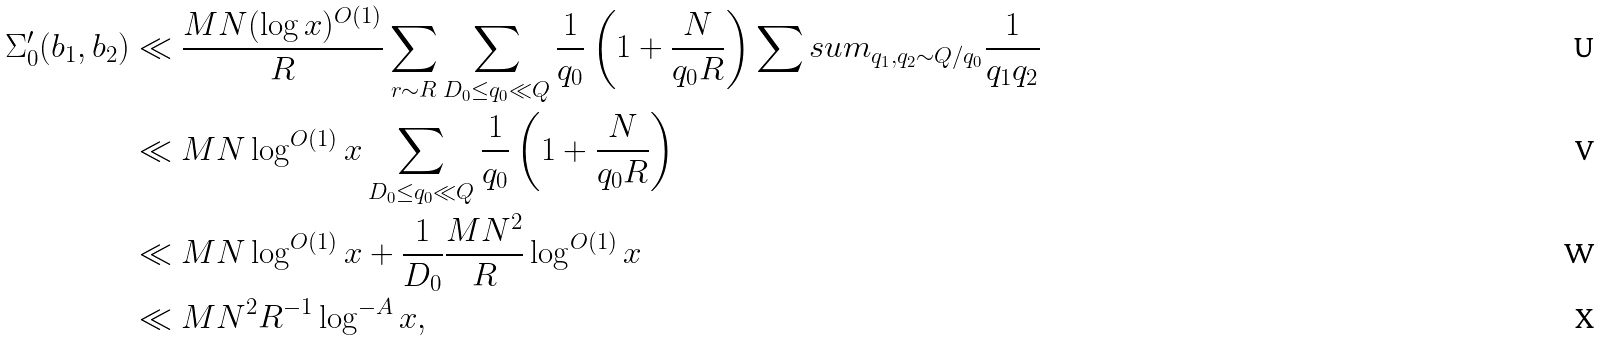<formula> <loc_0><loc_0><loc_500><loc_500>\Sigma ^ { \prime } _ { 0 } ( b _ { 1 } , b _ { 2 } ) & \ll \frac { M N ( \log x ) ^ { O ( 1 ) } } { R } \sum _ { r \sim R } \sum _ { D _ { 0 } \leq q _ { 0 } \ll Q } \frac { 1 } { q _ { 0 } } \left ( 1 + \frac { N } { q _ { 0 } R } \right ) \sum s u m _ { q _ { 1 } , q _ { 2 } \sim Q / q _ { 0 } } \frac { 1 } { q _ { 1 } q _ { 2 } } \\ & \ll M N \log ^ { O ( 1 ) } x \sum _ { D _ { 0 } \leq q _ { 0 } \ll Q } \frac { 1 } { q _ { 0 } } \left ( 1 + \frac { N } { q _ { 0 } R } \right ) \\ & \ll M N \log ^ { O ( 1 ) } x + \frac { 1 } { D _ { 0 } } \frac { M N ^ { 2 } } { R } \log ^ { O ( 1 ) } x \\ & \ll M N ^ { 2 } R ^ { - 1 } \log ^ { - A } x ,</formula> 